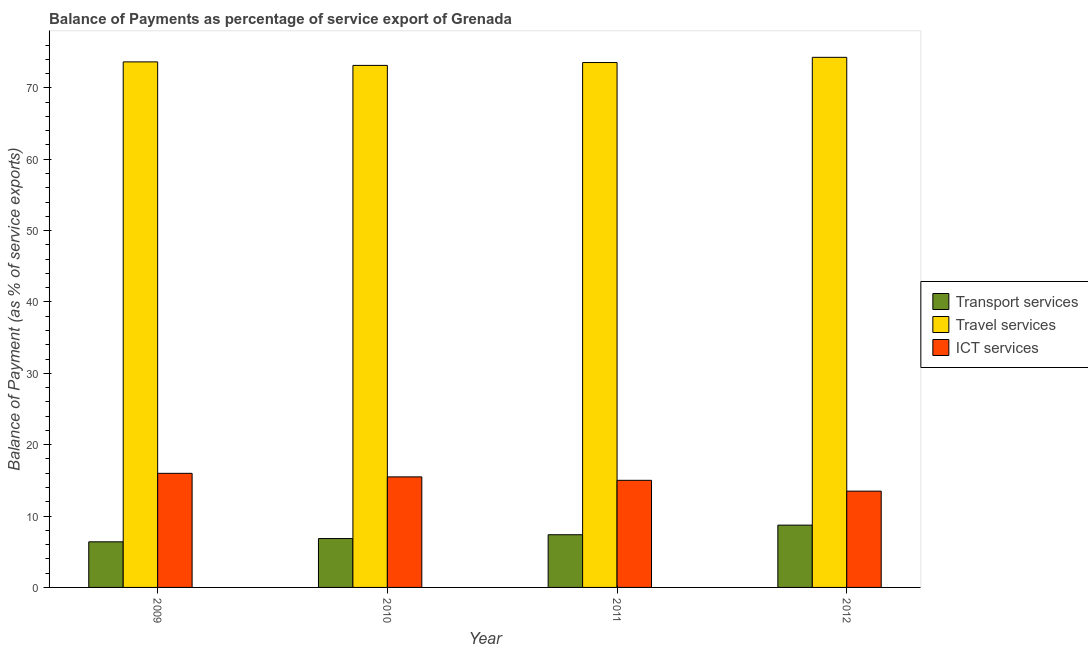How many different coloured bars are there?
Give a very brief answer. 3. How many groups of bars are there?
Your answer should be very brief. 4. Are the number of bars per tick equal to the number of legend labels?
Provide a succinct answer. Yes. Are the number of bars on each tick of the X-axis equal?
Your answer should be compact. Yes. How many bars are there on the 4th tick from the left?
Ensure brevity in your answer.  3. How many bars are there on the 1st tick from the right?
Keep it short and to the point. 3. What is the label of the 2nd group of bars from the left?
Offer a very short reply. 2010. What is the balance of payment of ict services in 2009?
Provide a short and direct response. 15.99. Across all years, what is the maximum balance of payment of transport services?
Provide a succinct answer. 8.73. Across all years, what is the minimum balance of payment of travel services?
Give a very brief answer. 73.15. In which year was the balance of payment of ict services maximum?
Offer a terse response. 2009. In which year was the balance of payment of ict services minimum?
Your answer should be compact. 2012. What is the total balance of payment of travel services in the graph?
Keep it short and to the point. 294.6. What is the difference between the balance of payment of transport services in 2011 and that in 2012?
Make the answer very short. -1.35. What is the difference between the balance of payment of transport services in 2011 and the balance of payment of ict services in 2009?
Keep it short and to the point. 0.99. What is the average balance of payment of travel services per year?
Your response must be concise. 73.65. What is the ratio of the balance of payment of ict services in 2011 to that in 2012?
Provide a succinct answer. 1.11. Is the difference between the balance of payment of ict services in 2009 and 2010 greater than the difference between the balance of payment of transport services in 2009 and 2010?
Your response must be concise. No. What is the difference between the highest and the second highest balance of payment of travel services?
Offer a terse response. 0.64. What is the difference between the highest and the lowest balance of payment of transport services?
Offer a very short reply. 2.34. What does the 1st bar from the left in 2012 represents?
Provide a succinct answer. Transport services. What does the 2nd bar from the right in 2012 represents?
Offer a terse response. Travel services. How many bars are there?
Your response must be concise. 12. How many years are there in the graph?
Keep it short and to the point. 4. What is the difference between two consecutive major ticks on the Y-axis?
Your response must be concise. 10. Does the graph contain any zero values?
Keep it short and to the point. No. How many legend labels are there?
Keep it short and to the point. 3. How are the legend labels stacked?
Keep it short and to the point. Vertical. What is the title of the graph?
Ensure brevity in your answer.  Balance of Payments as percentage of service export of Grenada. What is the label or title of the Y-axis?
Keep it short and to the point. Balance of Payment (as % of service exports). What is the Balance of Payment (as % of service exports) in Transport services in 2009?
Ensure brevity in your answer.  6.39. What is the Balance of Payment (as % of service exports) in Travel services in 2009?
Make the answer very short. 73.64. What is the Balance of Payment (as % of service exports) in ICT services in 2009?
Offer a terse response. 15.99. What is the Balance of Payment (as % of service exports) in Transport services in 2010?
Your answer should be compact. 6.85. What is the Balance of Payment (as % of service exports) of Travel services in 2010?
Provide a succinct answer. 73.15. What is the Balance of Payment (as % of service exports) in ICT services in 2010?
Your answer should be compact. 15.49. What is the Balance of Payment (as % of service exports) of Transport services in 2011?
Your answer should be compact. 7.38. What is the Balance of Payment (as % of service exports) in Travel services in 2011?
Make the answer very short. 73.55. What is the Balance of Payment (as % of service exports) of ICT services in 2011?
Offer a very short reply. 15.01. What is the Balance of Payment (as % of service exports) of Transport services in 2012?
Provide a succinct answer. 8.73. What is the Balance of Payment (as % of service exports) of Travel services in 2012?
Provide a short and direct response. 74.28. What is the Balance of Payment (as % of service exports) of ICT services in 2012?
Offer a terse response. 13.49. Across all years, what is the maximum Balance of Payment (as % of service exports) of Transport services?
Your answer should be compact. 8.73. Across all years, what is the maximum Balance of Payment (as % of service exports) of Travel services?
Offer a very short reply. 74.28. Across all years, what is the maximum Balance of Payment (as % of service exports) in ICT services?
Your answer should be very brief. 15.99. Across all years, what is the minimum Balance of Payment (as % of service exports) in Transport services?
Keep it short and to the point. 6.39. Across all years, what is the minimum Balance of Payment (as % of service exports) in Travel services?
Offer a very short reply. 73.15. Across all years, what is the minimum Balance of Payment (as % of service exports) in ICT services?
Your answer should be compact. 13.49. What is the total Balance of Payment (as % of service exports) in Transport services in the graph?
Provide a short and direct response. 29.35. What is the total Balance of Payment (as % of service exports) of Travel services in the graph?
Offer a very short reply. 294.6. What is the total Balance of Payment (as % of service exports) in ICT services in the graph?
Ensure brevity in your answer.  59.97. What is the difference between the Balance of Payment (as % of service exports) of Transport services in 2009 and that in 2010?
Ensure brevity in your answer.  -0.46. What is the difference between the Balance of Payment (as % of service exports) in Travel services in 2009 and that in 2010?
Ensure brevity in your answer.  0.49. What is the difference between the Balance of Payment (as % of service exports) in ICT services in 2009 and that in 2010?
Give a very brief answer. 0.5. What is the difference between the Balance of Payment (as % of service exports) in Transport services in 2009 and that in 2011?
Your response must be concise. -0.99. What is the difference between the Balance of Payment (as % of service exports) of Travel services in 2009 and that in 2011?
Your response must be concise. 0.09. What is the difference between the Balance of Payment (as % of service exports) in ICT services in 2009 and that in 2011?
Your answer should be compact. 0.98. What is the difference between the Balance of Payment (as % of service exports) of Transport services in 2009 and that in 2012?
Ensure brevity in your answer.  -2.34. What is the difference between the Balance of Payment (as % of service exports) of Travel services in 2009 and that in 2012?
Provide a succinct answer. -0.64. What is the difference between the Balance of Payment (as % of service exports) of ICT services in 2009 and that in 2012?
Offer a very short reply. 2.49. What is the difference between the Balance of Payment (as % of service exports) of Transport services in 2010 and that in 2011?
Offer a terse response. -0.53. What is the difference between the Balance of Payment (as % of service exports) in Travel services in 2010 and that in 2011?
Provide a short and direct response. -0.4. What is the difference between the Balance of Payment (as % of service exports) of ICT services in 2010 and that in 2011?
Provide a succinct answer. 0.48. What is the difference between the Balance of Payment (as % of service exports) in Transport services in 2010 and that in 2012?
Offer a terse response. -1.88. What is the difference between the Balance of Payment (as % of service exports) in Travel services in 2010 and that in 2012?
Your answer should be compact. -1.13. What is the difference between the Balance of Payment (as % of service exports) of ICT services in 2010 and that in 2012?
Offer a very short reply. 2. What is the difference between the Balance of Payment (as % of service exports) in Transport services in 2011 and that in 2012?
Your answer should be very brief. -1.35. What is the difference between the Balance of Payment (as % of service exports) in Travel services in 2011 and that in 2012?
Give a very brief answer. -0.73. What is the difference between the Balance of Payment (as % of service exports) of ICT services in 2011 and that in 2012?
Ensure brevity in your answer.  1.52. What is the difference between the Balance of Payment (as % of service exports) in Transport services in 2009 and the Balance of Payment (as % of service exports) in Travel services in 2010?
Provide a succinct answer. -66.76. What is the difference between the Balance of Payment (as % of service exports) in Transport services in 2009 and the Balance of Payment (as % of service exports) in ICT services in 2010?
Your answer should be compact. -9.1. What is the difference between the Balance of Payment (as % of service exports) in Travel services in 2009 and the Balance of Payment (as % of service exports) in ICT services in 2010?
Your answer should be compact. 58.15. What is the difference between the Balance of Payment (as % of service exports) in Transport services in 2009 and the Balance of Payment (as % of service exports) in Travel services in 2011?
Keep it short and to the point. -67.16. What is the difference between the Balance of Payment (as % of service exports) of Transport services in 2009 and the Balance of Payment (as % of service exports) of ICT services in 2011?
Your answer should be compact. -8.62. What is the difference between the Balance of Payment (as % of service exports) of Travel services in 2009 and the Balance of Payment (as % of service exports) of ICT services in 2011?
Provide a succinct answer. 58.63. What is the difference between the Balance of Payment (as % of service exports) in Transport services in 2009 and the Balance of Payment (as % of service exports) in Travel services in 2012?
Keep it short and to the point. -67.89. What is the difference between the Balance of Payment (as % of service exports) of Transport services in 2009 and the Balance of Payment (as % of service exports) of ICT services in 2012?
Your response must be concise. -7.1. What is the difference between the Balance of Payment (as % of service exports) in Travel services in 2009 and the Balance of Payment (as % of service exports) in ICT services in 2012?
Your answer should be very brief. 60.15. What is the difference between the Balance of Payment (as % of service exports) of Transport services in 2010 and the Balance of Payment (as % of service exports) of Travel services in 2011?
Offer a terse response. -66.7. What is the difference between the Balance of Payment (as % of service exports) in Transport services in 2010 and the Balance of Payment (as % of service exports) in ICT services in 2011?
Keep it short and to the point. -8.16. What is the difference between the Balance of Payment (as % of service exports) in Travel services in 2010 and the Balance of Payment (as % of service exports) in ICT services in 2011?
Your answer should be compact. 58.14. What is the difference between the Balance of Payment (as % of service exports) of Transport services in 2010 and the Balance of Payment (as % of service exports) of Travel services in 2012?
Offer a very short reply. -67.43. What is the difference between the Balance of Payment (as % of service exports) of Transport services in 2010 and the Balance of Payment (as % of service exports) of ICT services in 2012?
Provide a succinct answer. -6.64. What is the difference between the Balance of Payment (as % of service exports) of Travel services in 2010 and the Balance of Payment (as % of service exports) of ICT services in 2012?
Your response must be concise. 59.65. What is the difference between the Balance of Payment (as % of service exports) of Transport services in 2011 and the Balance of Payment (as % of service exports) of Travel services in 2012?
Offer a terse response. -66.89. What is the difference between the Balance of Payment (as % of service exports) of Transport services in 2011 and the Balance of Payment (as % of service exports) of ICT services in 2012?
Give a very brief answer. -6.11. What is the difference between the Balance of Payment (as % of service exports) in Travel services in 2011 and the Balance of Payment (as % of service exports) in ICT services in 2012?
Ensure brevity in your answer.  60.06. What is the average Balance of Payment (as % of service exports) in Transport services per year?
Your answer should be very brief. 7.34. What is the average Balance of Payment (as % of service exports) of Travel services per year?
Offer a terse response. 73.65. What is the average Balance of Payment (as % of service exports) in ICT services per year?
Make the answer very short. 14.99. In the year 2009, what is the difference between the Balance of Payment (as % of service exports) in Transport services and Balance of Payment (as % of service exports) in Travel services?
Keep it short and to the point. -67.25. In the year 2009, what is the difference between the Balance of Payment (as % of service exports) of Transport services and Balance of Payment (as % of service exports) of ICT services?
Your answer should be compact. -9.6. In the year 2009, what is the difference between the Balance of Payment (as % of service exports) of Travel services and Balance of Payment (as % of service exports) of ICT services?
Offer a terse response. 57.65. In the year 2010, what is the difference between the Balance of Payment (as % of service exports) in Transport services and Balance of Payment (as % of service exports) in Travel services?
Your answer should be very brief. -66.3. In the year 2010, what is the difference between the Balance of Payment (as % of service exports) of Transport services and Balance of Payment (as % of service exports) of ICT services?
Keep it short and to the point. -8.64. In the year 2010, what is the difference between the Balance of Payment (as % of service exports) in Travel services and Balance of Payment (as % of service exports) in ICT services?
Your answer should be very brief. 57.66. In the year 2011, what is the difference between the Balance of Payment (as % of service exports) of Transport services and Balance of Payment (as % of service exports) of Travel services?
Your answer should be compact. -66.17. In the year 2011, what is the difference between the Balance of Payment (as % of service exports) in Transport services and Balance of Payment (as % of service exports) in ICT services?
Offer a very short reply. -7.63. In the year 2011, what is the difference between the Balance of Payment (as % of service exports) in Travel services and Balance of Payment (as % of service exports) in ICT services?
Your answer should be compact. 58.54. In the year 2012, what is the difference between the Balance of Payment (as % of service exports) in Transport services and Balance of Payment (as % of service exports) in Travel services?
Make the answer very short. -65.55. In the year 2012, what is the difference between the Balance of Payment (as % of service exports) in Transport services and Balance of Payment (as % of service exports) in ICT services?
Offer a terse response. -4.76. In the year 2012, what is the difference between the Balance of Payment (as % of service exports) of Travel services and Balance of Payment (as % of service exports) of ICT services?
Your response must be concise. 60.78. What is the ratio of the Balance of Payment (as % of service exports) of Transport services in 2009 to that in 2010?
Ensure brevity in your answer.  0.93. What is the ratio of the Balance of Payment (as % of service exports) of ICT services in 2009 to that in 2010?
Offer a very short reply. 1.03. What is the ratio of the Balance of Payment (as % of service exports) of Transport services in 2009 to that in 2011?
Provide a succinct answer. 0.87. What is the ratio of the Balance of Payment (as % of service exports) in ICT services in 2009 to that in 2011?
Ensure brevity in your answer.  1.07. What is the ratio of the Balance of Payment (as % of service exports) of Transport services in 2009 to that in 2012?
Offer a very short reply. 0.73. What is the ratio of the Balance of Payment (as % of service exports) of ICT services in 2009 to that in 2012?
Your response must be concise. 1.18. What is the ratio of the Balance of Payment (as % of service exports) of Transport services in 2010 to that in 2011?
Provide a short and direct response. 0.93. What is the ratio of the Balance of Payment (as % of service exports) in Travel services in 2010 to that in 2011?
Make the answer very short. 0.99. What is the ratio of the Balance of Payment (as % of service exports) in ICT services in 2010 to that in 2011?
Provide a short and direct response. 1.03. What is the ratio of the Balance of Payment (as % of service exports) of Transport services in 2010 to that in 2012?
Ensure brevity in your answer.  0.78. What is the ratio of the Balance of Payment (as % of service exports) in Travel services in 2010 to that in 2012?
Your response must be concise. 0.98. What is the ratio of the Balance of Payment (as % of service exports) in ICT services in 2010 to that in 2012?
Give a very brief answer. 1.15. What is the ratio of the Balance of Payment (as % of service exports) in Transport services in 2011 to that in 2012?
Offer a terse response. 0.85. What is the ratio of the Balance of Payment (as % of service exports) of Travel services in 2011 to that in 2012?
Provide a succinct answer. 0.99. What is the ratio of the Balance of Payment (as % of service exports) in ICT services in 2011 to that in 2012?
Provide a short and direct response. 1.11. What is the difference between the highest and the second highest Balance of Payment (as % of service exports) of Transport services?
Your response must be concise. 1.35. What is the difference between the highest and the second highest Balance of Payment (as % of service exports) of Travel services?
Give a very brief answer. 0.64. What is the difference between the highest and the second highest Balance of Payment (as % of service exports) in ICT services?
Provide a succinct answer. 0.5. What is the difference between the highest and the lowest Balance of Payment (as % of service exports) of Transport services?
Ensure brevity in your answer.  2.34. What is the difference between the highest and the lowest Balance of Payment (as % of service exports) of Travel services?
Your answer should be very brief. 1.13. What is the difference between the highest and the lowest Balance of Payment (as % of service exports) in ICT services?
Offer a very short reply. 2.49. 